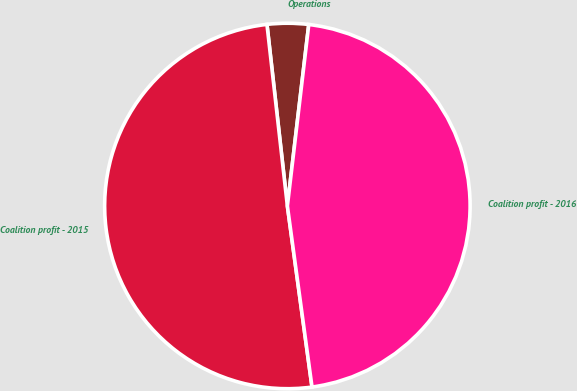<chart> <loc_0><loc_0><loc_500><loc_500><pie_chart><fcel>Operations<fcel>Coalition profit - 2015<fcel>Coalition profit - 2016<nl><fcel>3.65%<fcel>50.37%<fcel>45.98%<nl></chart> 